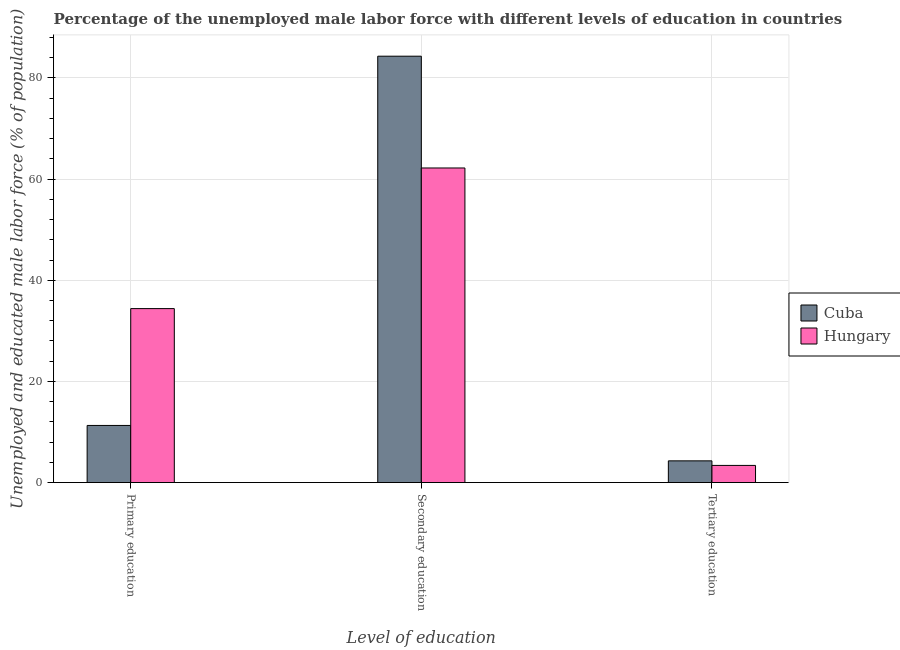How many groups of bars are there?
Make the answer very short. 3. How many bars are there on the 2nd tick from the left?
Make the answer very short. 2. How many bars are there on the 1st tick from the right?
Keep it short and to the point. 2. What is the label of the 3rd group of bars from the left?
Provide a short and direct response. Tertiary education. What is the percentage of male labor force who received tertiary education in Cuba?
Offer a very short reply. 4.3. Across all countries, what is the maximum percentage of male labor force who received secondary education?
Ensure brevity in your answer.  84.3. Across all countries, what is the minimum percentage of male labor force who received tertiary education?
Your answer should be compact. 3.4. In which country was the percentage of male labor force who received tertiary education maximum?
Your answer should be very brief. Cuba. In which country was the percentage of male labor force who received secondary education minimum?
Provide a short and direct response. Hungary. What is the total percentage of male labor force who received tertiary education in the graph?
Offer a terse response. 7.7. What is the difference between the percentage of male labor force who received secondary education in Cuba and that in Hungary?
Offer a terse response. 22.1. What is the difference between the percentage of male labor force who received primary education in Cuba and the percentage of male labor force who received tertiary education in Hungary?
Provide a short and direct response. 7.9. What is the average percentage of male labor force who received secondary education per country?
Give a very brief answer. 73.25. What is the difference between the percentage of male labor force who received primary education and percentage of male labor force who received secondary education in Hungary?
Offer a terse response. -27.8. In how many countries, is the percentage of male labor force who received tertiary education greater than 36 %?
Make the answer very short. 0. What is the ratio of the percentage of male labor force who received secondary education in Hungary to that in Cuba?
Offer a very short reply. 0.74. Is the percentage of male labor force who received secondary education in Hungary less than that in Cuba?
Ensure brevity in your answer.  Yes. Is the difference between the percentage of male labor force who received tertiary education in Cuba and Hungary greater than the difference between the percentage of male labor force who received primary education in Cuba and Hungary?
Ensure brevity in your answer.  Yes. What is the difference between the highest and the second highest percentage of male labor force who received secondary education?
Offer a very short reply. 22.1. What is the difference between the highest and the lowest percentage of male labor force who received primary education?
Give a very brief answer. 23.1. Is the sum of the percentage of male labor force who received primary education in Hungary and Cuba greater than the maximum percentage of male labor force who received tertiary education across all countries?
Give a very brief answer. Yes. What does the 2nd bar from the left in Secondary education represents?
Keep it short and to the point. Hungary. What does the 1st bar from the right in Secondary education represents?
Offer a very short reply. Hungary. How many bars are there?
Provide a succinct answer. 6. How many countries are there in the graph?
Ensure brevity in your answer.  2. What is the difference between two consecutive major ticks on the Y-axis?
Your answer should be very brief. 20. Are the values on the major ticks of Y-axis written in scientific E-notation?
Offer a very short reply. No. Does the graph contain any zero values?
Your response must be concise. No. What is the title of the graph?
Your answer should be compact. Percentage of the unemployed male labor force with different levels of education in countries. What is the label or title of the X-axis?
Give a very brief answer. Level of education. What is the label or title of the Y-axis?
Your answer should be very brief. Unemployed and educated male labor force (% of population). What is the Unemployed and educated male labor force (% of population) in Cuba in Primary education?
Provide a short and direct response. 11.3. What is the Unemployed and educated male labor force (% of population) of Hungary in Primary education?
Offer a terse response. 34.4. What is the Unemployed and educated male labor force (% of population) of Cuba in Secondary education?
Give a very brief answer. 84.3. What is the Unemployed and educated male labor force (% of population) of Hungary in Secondary education?
Keep it short and to the point. 62.2. What is the Unemployed and educated male labor force (% of population) in Cuba in Tertiary education?
Ensure brevity in your answer.  4.3. What is the Unemployed and educated male labor force (% of population) in Hungary in Tertiary education?
Your response must be concise. 3.4. Across all Level of education, what is the maximum Unemployed and educated male labor force (% of population) of Cuba?
Your answer should be compact. 84.3. Across all Level of education, what is the maximum Unemployed and educated male labor force (% of population) in Hungary?
Your response must be concise. 62.2. Across all Level of education, what is the minimum Unemployed and educated male labor force (% of population) in Cuba?
Provide a succinct answer. 4.3. Across all Level of education, what is the minimum Unemployed and educated male labor force (% of population) of Hungary?
Offer a terse response. 3.4. What is the total Unemployed and educated male labor force (% of population) of Cuba in the graph?
Your answer should be compact. 99.9. What is the total Unemployed and educated male labor force (% of population) in Hungary in the graph?
Provide a succinct answer. 100. What is the difference between the Unemployed and educated male labor force (% of population) of Cuba in Primary education and that in Secondary education?
Offer a very short reply. -73. What is the difference between the Unemployed and educated male labor force (% of population) of Hungary in Primary education and that in Secondary education?
Give a very brief answer. -27.8. What is the difference between the Unemployed and educated male labor force (% of population) in Cuba in Primary education and that in Tertiary education?
Your answer should be very brief. 7. What is the difference between the Unemployed and educated male labor force (% of population) of Hungary in Primary education and that in Tertiary education?
Keep it short and to the point. 31. What is the difference between the Unemployed and educated male labor force (% of population) of Hungary in Secondary education and that in Tertiary education?
Offer a very short reply. 58.8. What is the difference between the Unemployed and educated male labor force (% of population) in Cuba in Primary education and the Unemployed and educated male labor force (% of population) in Hungary in Secondary education?
Your answer should be very brief. -50.9. What is the difference between the Unemployed and educated male labor force (% of population) of Cuba in Primary education and the Unemployed and educated male labor force (% of population) of Hungary in Tertiary education?
Provide a succinct answer. 7.9. What is the difference between the Unemployed and educated male labor force (% of population) in Cuba in Secondary education and the Unemployed and educated male labor force (% of population) in Hungary in Tertiary education?
Offer a very short reply. 80.9. What is the average Unemployed and educated male labor force (% of population) in Cuba per Level of education?
Give a very brief answer. 33.3. What is the average Unemployed and educated male labor force (% of population) of Hungary per Level of education?
Offer a very short reply. 33.33. What is the difference between the Unemployed and educated male labor force (% of population) of Cuba and Unemployed and educated male labor force (% of population) of Hungary in Primary education?
Your answer should be compact. -23.1. What is the difference between the Unemployed and educated male labor force (% of population) in Cuba and Unemployed and educated male labor force (% of population) in Hungary in Secondary education?
Give a very brief answer. 22.1. What is the difference between the Unemployed and educated male labor force (% of population) of Cuba and Unemployed and educated male labor force (% of population) of Hungary in Tertiary education?
Your answer should be very brief. 0.9. What is the ratio of the Unemployed and educated male labor force (% of population) in Cuba in Primary education to that in Secondary education?
Offer a very short reply. 0.13. What is the ratio of the Unemployed and educated male labor force (% of population) of Hungary in Primary education to that in Secondary education?
Your answer should be very brief. 0.55. What is the ratio of the Unemployed and educated male labor force (% of population) in Cuba in Primary education to that in Tertiary education?
Offer a terse response. 2.63. What is the ratio of the Unemployed and educated male labor force (% of population) in Hungary in Primary education to that in Tertiary education?
Your answer should be very brief. 10.12. What is the ratio of the Unemployed and educated male labor force (% of population) in Cuba in Secondary education to that in Tertiary education?
Offer a very short reply. 19.6. What is the ratio of the Unemployed and educated male labor force (% of population) in Hungary in Secondary education to that in Tertiary education?
Your response must be concise. 18.29. What is the difference between the highest and the second highest Unemployed and educated male labor force (% of population) in Hungary?
Provide a short and direct response. 27.8. What is the difference between the highest and the lowest Unemployed and educated male labor force (% of population) in Cuba?
Provide a short and direct response. 80. What is the difference between the highest and the lowest Unemployed and educated male labor force (% of population) in Hungary?
Give a very brief answer. 58.8. 